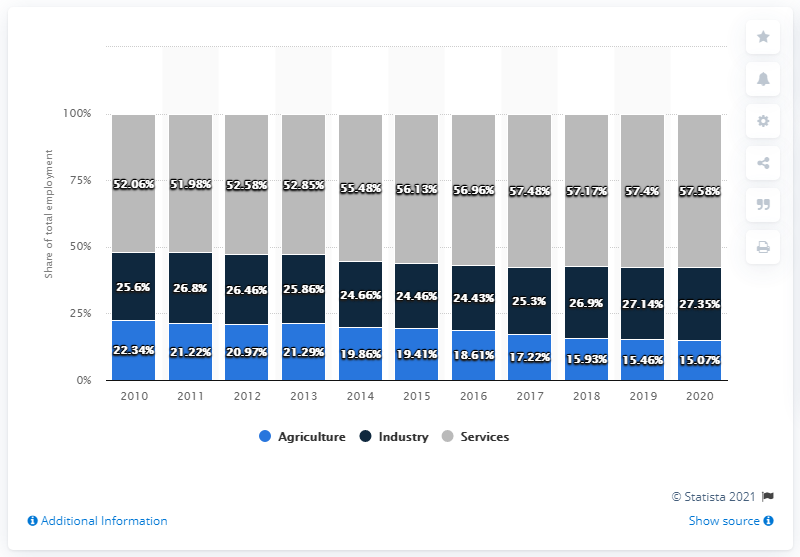Identify some key points in this picture. The difference between the highest and lowest share of employees in the agriculture sector is 7.27%. The color gray is commonly associated with the service industry in many contexts. 